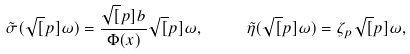<formula> <loc_0><loc_0><loc_500><loc_500>\tilde { \sigma } ( \sqrt { [ } p ] { \omega } ) = \frac { \sqrt { [ } p ] { b } } { \Phi ( x ) } \sqrt { [ } p ] { \omega } , \quad \ \tilde { \eta } ( \sqrt { [ } p ] { \omega } ) = \zeta _ { p } \sqrt { [ } p ] { \omega } ,</formula> 